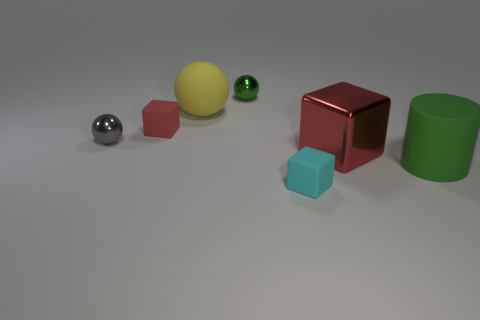Subtract all gray balls. How many red cubes are left? 2 Add 1 small cyan rubber cylinders. How many objects exist? 8 Subtract all small spheres. How many spheres are left? 1 Subtract all cylinders. How many objects are left? 6 Add 2 red matte objects. How many red matte objects exist? 3 Subtract 1 cyan blocks. How many objects are left? 6 Subtract all purple spheres. Subtract all blue blocks. How many spheres are left? 3 Subtract all small rubber blocks. Subtract all big things. How many objects are left? 2 Add 6 tiny rubber cubes. How many tiny rubber cubes are left? 8 